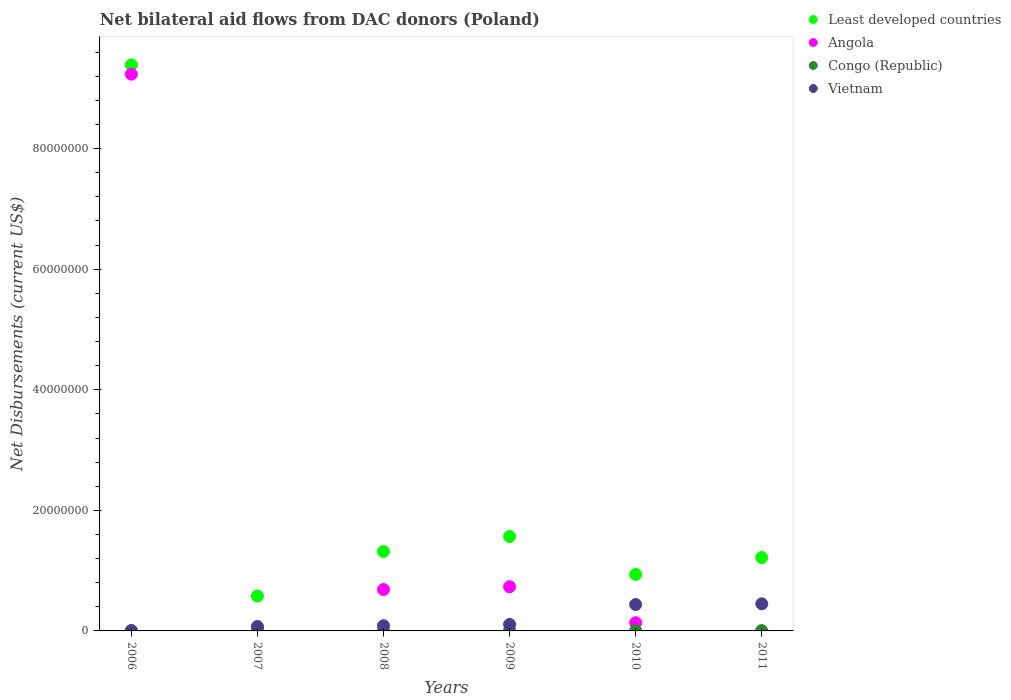What is the net bilateral aid flows in Vietnam in 2008?
Your response must be concise. 8.60e+05. Across all years, what is the maximum net bilateral aid flows in Least developed countries?
Your answer should be compact. 9.39e+07. Across all years, what is the minimum net bilateral aid flows in Vietnam?
Your answer should be very brief. 6.00e+04. In which year was the net bilateral aid flows in Least developed countries maximum?
Give a very brief answer. 2006. What is the total net bilateral aid flows in Vietnam in the graph?
Make the answer very short. 1.16e+07. What is the difference between the net bilateral aid flows in Congo (Republic) in 2007 and that in 2009?
Keep it short and to the point. 0. What is the difference between the net bilateral aid flows in Vietnam in 2009 and the net bilateral aid flows in Angola in 2008?
Make the answer very short. -5.79e+06. What is the average net bilateral aid flows in Least developed countries per year?
Make the answer very short. 2.50e+07. In the year 2011, what is the difference between the net bilateral aid flows in Congo (Republic) and net bilateral aid flows in Least developed countries?
Keep it short and to the point. -1.21e+07. What is the difference between the highest and the second highest net bilateral aid flows in Angola?
Offer a terse response. 8.50e+07. What is the difference between the highest and the lowest net bilateral aid flows in Angola?
Keep it short and to the point. 9.24e+07. Is the sum of the net bilateral aid flows in Congo (Republic) in 2007 and 2008 greater than the maximum net bilateral aid flows in Vietnam across all years?
Offer a terse response. No. Is it the case that in every year, the sum of the net bilateral aid flows in Vietnam and net bilateral aid flows in Least developed countries  is greater than the sum of net bilateral aid flows in Congo (Republic) and net bilateral aid flows in Angola?
Ensure brevity in your answer.  No. Is it the case that in every year, the sum of the net bilateral aid flows in Vietnam and net bilateral aid flows in Congo (Republic)  is greater than the net bilateral aid flows in Angola?
Offer a very short reply. No. Does the net bilateral aid flows in Vietnam monotonically increase over the years?
Offer a terse response. Yes. Is the net bilateral aid flows in Congo (Republic) strictly less than the net bilateral aid flows in Vietnam over the years?
Your answer should be very brief. Yes. Are the values on the major ticks of Y-axis written in scientific E-notation?
Your answer should be very brief. No. Does the graph contain any zero values?
Make the answer very short. Yes. How many legend labels are there?
Provide a succinct answer. 4. How are the legend labels stacked?
Your answer should be compact. Vertical. What is the title of the graph?
Make the answer very short. Net bilateral aid flows from DAC donors (Poland). What is the label or title of the Y-axis?
Keep it short and to the point. Net Disbursements (current US$). What is the Net Disbursements (current US$) of Least developed countries in 2006?
Provide a short and direct response. 9.39e+07. What is the Net Disbursements (current US$) in Angola in 2006?
Your answer should be very brief. 9.24e+07. What is the Net Disbursements (current US$) in Congo (Republic) in 2006?
Ensure brevity in your answer.  2.00e+04. What is the Net Disbursements (current US$) of Vietnam in 2006?
Keep it short and to the point. 6.00e+04. What is the Net Disbursements (current US$) of Least developed countries in 2007?
Keep it short and to the point. 5.79e+06. What is the Net Disbursements (current US$) of Vietnam in 2007?
Provide a succinct answer. 7.40e+05. What is the Net Disbursements (current US$) of Least developed countries in 2008?
Your answer should be compact. 1.32e+07. What is the Net Disbursements (current US$) in Angola in 2008?
Provide a succinct answer. 6.87e+06. What is the Net Disbursements (current US$) of Vietnam in 2008?
Your answer should be compact. 8.60e+05. What is the Net Disbursements (current US$) of Least developed countries in 2009?
Ensure brevity in your answer.  1.57e+07. What is the Net Disbursements (current US$) in Angola in 2009?
Make the answer very short. 7.33e+06. What is the Net Disbursements (current US$) in Vietnam in 2009?
Your answer should be compact. 1.08e+06. What is the Net Disbursements (current US$) of Least developed countries in 2010?
Your response must be concise. 9.37e+06. What is the Net Disbursements (current US$) of Angola in 2010?
Your answer should be very brief. 1.37e+06. What is the Net Disbursements (current US$) of Congo (Republic) in 2010?
Give a very brief answer. 4.00e+04. What is the Net Disbursements (current US$) in Vietnam in 2010?
Provide a succinct answer. 4.38e+06. What is the Net Disbursements (current US$) in Least developed countries in 2011?
Keep it short and to the point. 1.22e+07. What is the Net Disbursements (current US$) of Angola in 2011?
Your response must be concise. 0. What is the Net Disbursements (current US$) in Vietnam in 2011?
Provide a short and direct response. 4.50e+06. Across all years, what is the maximum Net Disbursements (current US$) in Least developed countries?
Make the answer very short. 9.39e+07. Across all years, what is the maximum Net Disbursements (current US$) in Angola?
Your response must be concise. 9.24e+07. Across all years, what is the maximum Net Disbursements (current US$) in Congo (Republic)?
Offer a terse response. 1.10e+05. Across all years, what is the maximum Net Disbursements (current US$) in Vietnam?
Keep it short and to the point. 4.50e+06. Across all years, what is the minimum Net Disbursements (current US$) of Least developed countries?
Provide a succinct answer. 5.79e+06. Across all years, what is the minimum Net Disbursements (current US$) in Vietnam?
Your answer should be compact. 6.00e+04. What is the total Net Disbursements (current US$) in Least developed countries in the graph?
Your answer should be very brief. 1.50e+08. What is the total Net Disbursements (current US$) of Angola in the graph?
Your answer should be very brief. 1.08e+08. What is the total Net Disbursements (current US$) of Congo (Republic) in the graph?
Make the answer very short. 3.80e+05. What is the total Net Disbursements (current US$) of Vietnam in the graph?
Offer a very short reply. 1.16e+07. What is the difference between the Net Disbursements (current US$) in Least developed countries in 2006 and that in 2007?
Your response must be concise. 8.81e+07. What is the difference between the Net Disbursements (current US$) in Angola in 2006 and that in 2007?
Your response must be concise. 9.19e+07. What is the difference between the Net Disbursements (current US$) of Congo (Republic) in 2006 and that in 2007?
Provide a short and direct response. -9.00e+04. What is the difference between the Net Disbursements (current US$) of Vietnam in 2006 and that in 2007?
Offer a terse response. -6.80e+05. What is the difference between the Net Disbursements (current US$) in Least developed countries in 2006 and that in 2008?
Keep it short and to the point. 8.07e+07. What is the difference between the Net Disbursements (current US$) of Angola in 2006 and that in 2008?
Provide a succinct answer. 8.55e+07. What is the difference between the Net Disbursements (current US$) of Congo (Republic) in 2006 and that in 2008?
Offer a terse response. -3.00e+04. What is the difference between the Net Disbursements (current US$) of Vietnam in 2006 and that in 2008?
Provide a succinct answer. -8.00e+05. What is the difference between the Net Disbursements (current US$) in Least developed countries in 2006 and that in 2009?
Make the answer very short. 7.82e+07. What is the difference between the Net Disbursements (current US$) of Angola in 2006 and that in 2009?
Provide a succinct answer. 8.50e+07. What is the difference between the Net Disbursements (current US$) in Vietnam in 2006 and that in 2009?
Keep it short and to the point. -1.02e+06. What is the difference between the Net Disbursements (current US$) of Least developed countries in 2006 and that in 2010?
Offer a terse response. 8.45e+07. What is the difference between the Net Disbursements (current US$) of Angola in 2006 and that in 2010?
Your response must be concise. 9.10e+07. What is the difference between the Net Disbursements (current US$) in Congo (Republic) in 2006 and that in 2010?
Offer a very short reply. -2.00e+04. What is the difference between the Net Disbursements (current US$) of Vietnam in 2006 and that in 2010?
Ensure brevity in your answer.  -4.32e+06. What is the difference between the Net Disbursements (current US$) in Least developed countries in 2006 and that in 2011?
Provide a short and direct response. 8.17e+07. What is the difference between the Net Disbursements (current US$) in Congo (Republic) in 2006 and that in 2011?
Give a very brief answer. -3.00e+04. What is the difference between the Net Disbursements (current US$) of Vietnam in 2006 and that in 2011?
Offer a very short reply. -4.44e+06. What is the difference between the Net Disbursements (current US$) of Least developed countries in 2007 and that in 2008?
Your answer should be very brief. -7.38e+06. What is the difference between the Net Disbursements (current US$) in Angola in 2007 and that in 2008?
Your answer should be compact. -6.38e+06. What is the difference between the Net Disbursements (current US$) of Vietnam in 2007 and that in 2008?
Offer a very short reply. -1.20e+05. What is the difference between the Net Disbursements (current US$) of Least developed countries in 2007 and that in 2009?
Make the answer very short. -9.87e+06. What is the difference between the Net Disbursements (current US$) of Angola in 2007 and that in 2009?
Your response must be concise. -6.84e+06. What is the difference between the Net Disbursements (current US$) in Congo (Republic) in 2007 and that in 2009?
Your answer should be compact. 0. What is the difference between the Net Disbursements (current US$) in Vietnam in 2007 and that in 2009?
Offer a very short reply. -3.40e+05. What is the difference between the Net Disbursements (current US$) in Least developed countries in 2007 and that in 2010?
Offer a terse response. -3.58e+06. What is the difference between the Net Disbursements (current US$) in Angola in 2007 and that in 2010?
Provide a succinct answer. -8.80e+05. What is the difference between the Net Disbursements (current US$) in Vietnam in 2007 and that in 2010?
Provide a succinct answer. -3.64e+06. What is the difference between the Net Disbursements (current US$) in Least developed countries in 2007 and that in 2011?
Offer a terse response. -6.38e+06. What is the difference between the Net Disbursements (current US$) of Congo (Republic) in 2007 and that in 2011?
Keep it short and to the point. 6.00e+04. What is the difference between the Net Disbursements (current US$) in Vietnam in 2007 and that in 2011?
Ensure brevity in your answer.  -3.76e+06. What is the difference between the Net Disbursements (current US$) in Least developed countries in 2008 and that in 2009?
Provide a short and direct response. -2.49e+06. What is the difference between the Net Disbursements (current US$) of Angola in 2008 and that in 2009?
Provide a short and direct response. -4.60e+05. What is the difference between the Net Disbursements (current US$) in Congo (Republic) in 2008 and that in 2009?
Offer a terse response. -6.00e+04. What is the difference between the Net Disbursements (current US$) in Vietnam in 2008 and that in 2009?
Offer a very short reply. -2.20e+05. What is the difference between the Net Disbursements (current US$) of Least developed countries in 2008 and that in 2010?
Give a very brief answer. 3.80e+06. What is the difference between the Net Disbursements (current US$) of Angola in 2008 and that in 2010?
Offer a very short reply. 5.50e+06. What is the difference between the Net Disbursements (current US$) in Congo (Republic) in 2008 and that in 2010?
Provide a succinct answer. 10000. What is the difference between the Net Disbursements (current US$) in Vietnam in 2008 and that in 2010?
Offer a very short reply. -3.52e+06. What is the difference between the Net Disbursements (current US$) of Vietnam in 2008 and that in 2011?
Your answer should be very brief. -3.64e+06. What is the difference between the Net Disbursements (current US$) in Least developed countries in 2009 and that in 2010?
Keep it short and to the point. 6.29e+06. What is the difference between the Net Disbursements (current US$) in Angola in 2009 and that in 2010?
Give a very brief answer. 5.96e+06. What is the difference between the Net Disbursements (current US$) in Vietnam in 2009 and that in 2010?
Provide a short and direct response. -3.30e+06. What is the difference between the Net Disbursements (current US$) of Least developed countries in 2009 and that in 2011?
Give a very brief answer. 3.49e+06. What is the difference between the Net Disbursements (current US$) in Congo (Republic) in 2009 and that in 2011?
Provide a short and direct response. 6.00e+04. What is the difference between the Net Disbursements (current US$) of Vietnam in 2009 and that in 2011?
Ensure brevity in your answer.  -3.42e+06. What is the difference between the Net Disbursements (current US$) in Least developed countries in 2010 and that in 2011?
Make the answer very short. -2.80e+06. What is the difference between the Net Disbursements (current US$) in Congo (Republic) in 2010 and that in 2011?
Ensure brevity in your answer.  -10000. What is the difference between the Net Disbursements (current US$) in Least developed countries in 2006 and the Net Disbursements (current US$) in Angola in 2007?
Your answer should be compact. 9.34e+07. What is the difference between the Net Disbursements (current US$) of Least developed countries in 2006 and the Net Disbursements (current US$) of Congo (Republic) in 2007?
Give a very brief answer. 9.38e+07. What is the difference between the Net Disbursements (current US$) of Least developed countries in 2006 and the Net Disbursements (current US$) of Vietnam in 2007?
Your answer should be very brief. 9.32e+07. What is the difference between the Net Disbursements (current US$) of Angola in 2006 and the Net Disbursements (current US$) of Congo (Republic) in 2007?
Make the answer very short. 9.22e+07. What is the difference between the Net Disbursements (current US$) of Angola in 2006 and the Net Disbursements (current US$) of Vietnam in 2007?
Offer a terse response. 9.16e+07. What is the difference between the Net Disbursements (current US$) in Congo (Republic) in 2006 and the Net Disbursements (current US$) in Vietnam in 2007?
Ensure brevity in your answer.  -7.20e+05. What is the difference between the Net Disbursements (current US$) in Least developed countries in 2006 and the Net Disbursements (current US$) in Angola in 2008?
Your response must be concise. 8.70e+07. What is the difference between the Net Disbursements (current US$) in Least developed countries in 2006 and the Net Disbursements (current US$) in Congo (Republic) in 2008?
Your answer should be very brief. 9.38e+07. What is the difference between the Net Disbursements (current US$) in Least developed countries in 2006 and the Net Disbursements (current US$) in Vietnam in 2008?
Keep it short and to the point. 9.30e+07. What is the difference between the Net Disbursements (current US$) in Angola in 2006 and the Net Disbursements (current US$) in Congo (Republic) in 2008?
Provide a succinct answer. 9.23e+07. What is the difference between the Net Disbursements (current US$) of Angola in 2006 and the Net Disbursements (current US$) of Vietnam in 2008?
Provide a succinct answer. 9.15e+07. What is the difference between the Net Disbursements (current US$) of Congo (Republic) in 2006 and the Net Disbursements (current US$) of Vietnam in 2008?
Provide a short and direct response. -8.40e+05. What is the difference between the Net Disbursements (current US$) in Least developed countries in 2006 and the Net Disbursements (current US$) in Angola in 2009?
Keep it short and to the point. 8.66e+07. What is the difference between the Net Disbursements (current US$) in Least developed countries in 2006 and the Net Disbursements (current US$) in Congo (Republic) in 2009?
Your answer should be compact. 9.38e+07. What is the difference between the Net Disbursements (current US$) of Least developed countries in 2006 and the Net Disbursements (current US$) of Vietnam in 2009?
Your response must be concise. 9.28e+07. What is the difference between the Net Disbursements (current US$) of Angola in 2006 and the Net Disbursements (current US$) of Congo (Republic) in 2009?
Offer a terse response. 9.22e+07. What is the difference between the Net Disbursements (current US$) of Angola in 2006 and the Net Disbursements (current US$) of Vietnam in 2009?
Your response must be concise. 9.13e+07. What is the difference between the Net Disbursements (current US$) in Congo (Republic) in 2006 and the Net Disbursements (current US$) in Vietnam in 2009?
Your answer should be very brief. -1.06e+06. What is the difference between the Net Disbursements (current US$) in Least developed countries in 2006 and the Net Disbursements (current US$) in Angola in 2010?
Your answer should be compact. 9.25e+07. What is the difference between the Net Disbursements (current US$) of Least developed countries in 2006 and the Net Disbursements (current US$) of Congo (Republic) in 2010?
Your answer should be compact. 9.38e+07. What is the difference between the Net Disbursements (current US$) in Least developed countries in 2006 and the Net Disbursements (current US$) in Vietnam in 2010?
Your answer should be very brief. 8.95e+07. What is the difference between the Net Disbursements (current US$) of Angola in 2006 and the Net Disbursements (current US$) of Congo (Republic) in 2010?
Keep it short and to the point. 9.23e+07. What is the difference between the Net Disbursements (current US$) in Angola in 2006 and the Net Disbursements (current US$) in Vietnam in 2010?
Offer a terse response. 8.80e+07. What is the difference between the Net Disbursements (current US$) of Congo (Republic) in 2006 and the Net Disbursements (current US$) of Vietnam in 2010?
Offer a very short reply. -4.36e+06. What is the difference between the Net Disbursements (current US$) in Least developed countries in 2006 and the Net Disbursements (current US$) in Congo (Republic) in 2011?
Your answer should be very brief. 9.38e+07. What is the difference between the Net Disbursements (current US$) in Least developed countries in 2006 and the Net Disbursements (current US$) in Vietnam in 2011?
Make the answer very short. 8.94e+07. What is the difference between the Net Disbursements (current US$) in Angola in 2006 and the Net Disbursements (current US$) in Congo (Republic) in 2011?
Your answer should be compact. 9.23e+07. What is the difference between the Net Disbursements (current US$) in Angola in 2006 and the Net Disbursements (current US$) in Vietnam in 2011?
Your response must be concise. 8.78e+07. What is the difference between the Net Disbursements (current US$) in Congo (Republic) in 2006 and the Net Disbursements (current US$) in Vietnam in 2011?
Offer a terse response. -4.48e+06. What is the difference between the Net Disbursements (current US$) in Least developed countries in 2007 and the Net Disbursements (current US$) in Angola in 2008?
Provide a succinct answer. -1.08e+06. What is the difference between the Net Disbursements (current US$) in Least developed countries in 2007 and the Net Disbursements (current US$) in Congo (Republic) in 2008?
Your answer should be very brief. 5.74e+06. What is the difference between the Net Disbursements (current US$) of Least developed countries in 2007 and the Net Disbursements (current US$) of Vietnam in 2008?
Your response must be concise. 4.93e+06. What is the difference between the Net Disbursements (current US$) of Angola in 2007 and the Net Disbursements (current US$) of Congo (Republic) in 2008?
Offer a terse response. 4.40e+05. What is the difference between the Net Disbursements (current US$) in Angola in 2007 and the Net Disbursements (current US$) in Vietnam in 2008?
Make the answer very short. -3.70e+05. What is the difference between the Net Disbursements (current US$) of Congo (Republic) in 2007 and the Net Disbursements (current US$) of Vietnam in 2008?
Provide a short and direct response. -7.50e+05. What is the difference between the Net Disbursements (current US$) of Least developed countries in 2007 and the Net Disbursements (current US$) of Angola in 2009?
Offer a very short reply. -1.54e+06. What is the difference between the Net Disbursements (current US$) in Least developed countries in 2007 and the Net Disbursements (current US$) in Congo (Republic) in 2009?
Ensure brevity in your answer.  5.68e+06. What is the difference between the Net Disbursements (current US$) in Least developed countries in 2007 and the Net Disbursements (current US$) in Vietnam in 2009?
Your response must be concise. 4.71e+06. What is the difference between the Net Disbursements (current US$) in Angola in 2007 and the Net Disbursements (current US$) in Congo (Republic) in 2009?
Your answer should be very brief. 3.80e+05. What is the difference between the Net Disbursements (current US$) of Angola in 2007 and the Net Disbursements (current US$) of Vietnam in 2009?
Make the answer very short. -5.90e+05. What is the difference between the Net Disbursements (current US$) of Congo (Republic) in 2007 and the Net Disbursements (current US$) of Vietnam in 2009?
Give a very brief answer. -9.70e+05. What is the difference between the Net Disbursements (current US$) of Least developed countries in 2007 and the Net Disbursements (current US$) of Angola in 2010?
Offer a very short reply. 4.42e+06. What is the difference between the Net Disbursements (current US$) of Least developed countries in 2007 and the Net Disbursements (current US$) of Congo (Republic) in 2010?
Offer a terse response. 5.75e+06. What is the difference between the Net Disbursements (current US$) of Least developed countries in 2007 and the Net Disbursements (current US$) of Vietnam in 2010?
Offer a very short reply. 1.41e+06. What is the difference between the Net Disbursements (current US$) of Angola in 2007 and the Net Disbursements (current US$) of Congo (Republic) in 2010?
Offer a terse response. 4.50e+05. What is the difference between the Net Disbursements (current US$) in Angola in 2007 and the Net Disbursements (current US$) in Vietnam in 2010?
Ensure brevity in your answer.  -3.89e+06. What is the difference between the Net Disbursements (current US$) of Congo (Republic) in 2007 and the Net Disbursements (current US$) of Vietnam in 2010?
Make the answer very short. -4.27e+06. What is the difference between the Net Disbursements (current US$) of Least developed countries in 2007 and the Net Disbursements (current US$) of Congo (Republic) in 2011?
Keep it short and to the point. 5.74e+06. What is the difference between the Net Disbursements (current US$) of Least developed countries in 2007 and the Net Disbursements (current US$) of Vietnam in 2011?
Give a very brief answer. 1.29e+06. What is the difference between the Net Disbursements (current US$) in Angola in 2007 and the Net Disbursements (current US$) in Vietnam in 2011?
Give a very brief answer. -4.01e+06. What is the difference between the Net Disbursements (current US$) of Congo (Republic) in 2007 and the Net Disbursements (current US$) of Vietnam in 2011?
Your answer should be very brief. -4.39e+06. What is the difference between the Net Disbursements (current US$) of Least developed countries in 2008 and the Net Disbursements (current US$) of Angola in 2009?
Keep it short and to the point. 5.84e+06. What is the difference between the Net Disbursements (current US$) of Least developed countries in 2008 and the Net Disbursements (current US$) of Congo (Republic) in 2009?
Your response must be concise. 1.31e+07. What is the difference between the Net Disbursements (current US$) in Least developed countries in 2008 and the Net Disbursements (current US$) in Vietnam in 2009?
Your response must be concise. 1.21e+07. What is the difference between the Net Disbursements (current US$) of Angola in 2008 and the Net Disbursements (current US$) of Congo (Republic) in 2009?
Offer a very short reply. 6.76e+06. What is the difference between the Net Disbursements (current US$) in Angola in 2008 and the Net Disbursements (current US$) in Vietnam in 2009?
Offer a very short reply. 5.79e+06. What is the difference between the Net Disbursements (current US$) of Congo (Republic) in 2008 and the Net Disbursements (current US$) of Vietnam in 2009?
Make the answer very short. -1.03e+06. What is the difference between the Net Disbursements (current US$) in Least developed countries in 2008 and the Net Disbursements (current US$) in Angola in 2010?
Your answer should be very brief. 1.18e+07. What is the difference between the Net Disbursements (current US$) in Least developed countries in 2008 and the Net Disbursements (current US$) in Congo (Republic) in 2010?
Your response must be concise. 1.31e+07. What is the difference between the Net Disbursements (current US$) of Least developed countries in 2008 and the Net Disbursements (current US$) of Vietnam in 2010?
Keep it short and to the point. 8.79e+06. What is the difference between the Net Disbursements (current US$) of Angola in 2008 and the Net Disbursements (current US$) of Congo (Republic) in 2010?
Give a very brief answer. 6.83e+06. What is the difference between the Net Disbursements (current US$) of Angola in 2008 and the Net Disbursements (current US$) of Vietnam in 2010?
Your answer should be compact. 2.49e+06. What is the difference between the Net Disbursements (current US$) in Congo (Republic) in 2008 and the Net Disbursements (current US$) in Vietnam in 2010?
Your answer should be very brief. -4.33e+06. What is the difference between the Net Disbursements (current US$) of Least developed countries in 2008 and the Net Disbursements (current US$) of Congo (Republic) in 2011?
Your answer should be very brief. 1.31e+07. What is the difference between the Net Disbursements (current US$) of Least developed countries in 2008 and the Net Disbursements (current US$) of Vietnam in 2011?
Your answer should be very brief. 8.67e+06. What is the difference between the Net Disbursements (current US$) of Angola in 2008 and the Net Disbursements (current US$) of Congo (Republic) in 2011?
Provide a short and direct response. 6.82e+06. What is the difference between the Net Disbursements (current US$) of Angola in 2008 and the Net Disbursements (current US$) of Vietnam in 2011?
Keep it short and to the point. 2.37e+06. What is the difference between the Net Disbursements (current US$) of Congo (Republic) in 2008 and the Net Disbursements (current US$) of Vietnam in 2011?
Your answer should be very brief. -4.45e+06. What is the difference between the Net Disbursements (current US$) in Least developed countries in 2009 and the Net Disbursements (current US$) in Angola in 2010?
Keep it short and to the point. 1.43e+07. What is the difference between the Net Disbursements (current US$) of Least developed countries in 2009 and the Net Disbursements (current US$) of Congo (Republic) in 2010?
Your answer should be compact. 1.56e+07. What is the difference between the Net Disbursements (current US$) of Least developed countries in 2009 and the Net Disbursements (current US$) of Vietnam in 2010?
Your answer should be very brief. 1.13e+07. What is the difference between the Net Disbursements (current US$) of Angola in 2009 and the Net Disbursements (current US$) of Congo (Republic) in 2010?
Offer a terse response. 7.29e+06. What is the difference between the Net Disbursements (current US$) of Angola in 2009 and the Net Disbursements (current US$) of Vietnam in 2010?
Give a very brief answer. 2.95e+06. What is the difference between the Net Disbursements (current US$) in Congo (Republic) in 2009 and the Net Disbursements (current US$) in Vietnam in 2010?
Keep it short and to the point. -4.27e+06. What is the difference between the Net Disbursements (current US$) of Least developed countries in 2009 and the Net Disbursements (current US$) of Congo (Republic) in 2011?
Offer a very short reply. 1.56e+07. What is the difference between the Net Disbursements (current US$) in Least developed countries in 2009 and the Net Disbursements (current US$) in Vietnam in 2011?
Offer a terse response. 1.12e+07. What is the difference between the Net Disbursements (current US$) in Angola in 2009 and the Net Disbursements (current US$) in Congo (Republic) in 2011?
Provide a succinct answer. 7.28e+06. What is the difference between the Net Disbursements (current US$) of Angola in 2009 and the Net Disbursements (current US$) of Vietnam in 2011?
Provide a succinct answer. 2.83e+06. What is the difference between the Net Disbursements (current US$) in Congo (Republic) in 2009 and the Net Disbursements (current US$) in Vietnam in 2011?
Your answer should be compact. -4.39e+06. What is the difference between the Net Disbursements (current US$) in Least developed countries in 2010 and the Net Disbursements (current US$) in Congo (Republic) in 2011?
Provide a succinct answer. 9.32e+06. What is the difference between the Net Disbursements (current US$) of Least developed countries in 2010 and the Net Disbursements (current US$) of Vietnam in 2011?
Offer a very short reply. 4.87e+06. What is the difference between the Net Disbursements (current US$) in Angola in 2010 and the Net Disbursements (current US$) in Congo (Republic) in 2011?
Ensure brevity in your answer.  1.32e+06. What is the difference between the Net Disbursements (current US$) of Angola in 2010 and the Net Disbursements (current US$) of Vietnam in 2011?
Ensure brevity in your answer.  -3.13e+06. What is the difference between the Net Disbursements (current US$) of Congo (Republic) in 2010 and the Net Disbursements (current US$) of Vietnam in 2011?
Offer a terse response. -4.46e+06. What is the average Net Disbursements (current US$) of Least developed countries per year?
Make the answer very short. 2.50e+07. What is the average Net Disbursements (current US$) of Angola per year?
Your answer should be very brief. 1.81e+07. What is the average Net Disbursements (current US$) in Congo (Republic) per year?
Make the answer very short. 6.33e+04. What is the average Net Disbursements (current US$) of Vietnam per year?
Ensure brevity in your answer.  1.94e+06. In the year 2006, what is the difference between the Net Disbursements (current US$) in Least developed countries and Net Disbursements (current US$) in Angola?
Ensure brevity in your answer.  1.54e+06. In the year 2006, what is the difference between the Net Disbursements (current US$) in Least developed countries and Net Disbursements (current US$) in Congo (Republic)?
Your response must be concise. 9.39e+07. In the year 2006, what is the difference between the Net Disbursements (current US$) in Least developed countries and Net Disbursements (current US$) in Vietnam?
Your answer should be very brief. 9.38e+07. In the year 2006, what is the difference between the Net Disbursements (current US$) in Angola and Net Disbursements (current US$) in Congo (Republic)?
Give a very brief answer. 9.23e+07. In the year 2006, what is the difference between the Net Disbursements (current US$) of Angola and Net Disbursements (current US$) of Vietnam?
Provide a short and direct response. 9.23e+07. In the year 2006, what is the difference between the Net Disbursements (current US$) of Congo (Republic) and Net Disbursements (current US$) of Vietnam?
Provide a short and direct response. -4.00e+04. In the year 2007, what is the difference between the Net Disbursements (current US$) of Least developed countries and Net Disbursements (current US$) of Angola?
Ensure brevity in your answer.  5.30e+06. In the year 2007, what is the difference between the Net Disbursements (current US$) in Least developed countries and Net Disbursements (current US$) in Congo (Republic)?
Keep it short and to the point. 5.68e+06. In the year 2007, what is the difference between the Net Disbursements (current US$) in Least developed countries and Net Disbursements (current US$) in Vietnam?
Provide a succinct answer. 5.05e+06. In the year 2007, what is the difference between the Net Disbursements (current US$) of Congo (Republic) and Net Disbursements (current US$) of Vietnam?
Your answer should be compact. -6.30e+05. In the year 2008, what is the difference between the Net Disbursements (current US$) in Least developed countries and Net Disbursements (current US$) in Angola?
Keep it short and to the point. 6.30e+06. In the year 2008, what is the difference between the Net Disbursements (current US$) of Least developed countries and Net Disbursements (current US$) of Congo (Republic)?
Keep it short and to the point. 1.31e+07. In the year 2008, what is the difference between the Net Disbursements (current US$) of Least developed countries and Net Disbursements (current US$) of Vietnam?
Ensure brevity in your answer.  1.23e+07. In the year 2008, what is the difference between the Net Disbursements (current US$) in Angola and Net Disbursements (current US$) in Congo (Republic)?
Your answer should be very brief. 6.82e+06. In the year 2008, what is the difference between the Net Disbursements (current US$) of Angola and Net Disbursements (current US$) of Vietnam?
Keep it short and to the point. 6.01e+06. In the year 2008, what is the difference between the Net Disbursements (current US$) of Congo (Republic) and Net Disbursements (current US$) of Vietnam?
Give a very brief answer. -8.10e+05. In the year 2009, what is the difference between the Net Disbursements (current US$) in Least developed countries and Net Disbursements (current US$) in Angola?
Make the answer very short. 8.33e+06. In the year 2009, what is the difference between the Net Disbursements (current US$) in Least developed countries and Net Disbursements (current US$) in Congo (Republic)?
Provide a short and direct response. 1.56e+07. In the year 2009, what is the difference between the Net Disbursements (current US$) in Least developed countries and Net Disbursements (current US$) in Vietnam?
Provide a short and direct response. 1.46e+07. In the year 2009, what is the difference between the Net Disbursements (current US$) of Angola and Net Disbursements (current US$) of Congo (Republic)?
Keep it short and to the point. 7.22e+06. In the year 2009, what is the difference between the Net Disbursements (current US$) of Angola and Net Disbursements (current US$) of Vietnam?
Provide a short and direct response. 6.25e+06. In the year 2009, what is the difference between the Net Disbursements (current US$) of Congo (Republic) and Net Disbursements (current US$) of Vietnam?
Your answer should be very brief. -9.70e+05. In the year 2010, what is the difference between the Net Disbursements (current US$) in Least developed countries and Net Disbursements (current US$) in Angola?
Provide a succinct answer. 8.00e+06. In the year 2010, what is the difference between the Net Disbursements (current US$) of Least developed countries and Net Disbursements (current US$) of Congo (Republic)?
Give a very brief answer. 9.33e+06. In the year 2010, what is the difference between the Net Disbursements (current US$) in Least developed countries and Net Disbursements (current US$) in Vietnam?
Your answer should be very brief. 4.99e+06. In the year 2010, what is the difference between the Net Disbursements (current US$) in Angola and Net Disbursements (current US$) in Congo (Republic)?
Your response must be concise. 1.33e+06. In the year 2010, what is the difference between the Net Disbursements (current US$) in Angola and Net Disbursements (current US$) in Vietnam?
Provide a short and direct response. -3.01e+06. In the year 2010, what is the difference between the Net Disbursements (current US$) of Congo (Republic) and Net Disbursements (current US$) of Vietnam?
Keep it short and to the point. -4.34e+06. In the year 2011, what is the difference between the Net Disbursements (current US$) in Least developed countries and Net Disbursements (current US$) in Congo (Republic)?
Keep it short and to the point. 1.21e+07. In the year 2011, what is the difference between the Net Disbursements (current US$) in Least developed countries and Net Disbursements (current US$) in Vietnam?
Offer a terse response. 7.67e+06. In the year 2011, what is the difference between the Net Disbursements (current US$) in Congo (Republic) and Net Disbursements (current US$) in Vietnam?
Provide a succinct answer. -4.45e+06. What is the ratio of the Net Disbursements (current US$) of Least developed countries in 2006 to that in 2007?
Provide a short and direct response. 16.22. What is the ratio of the Net Disbursements (current US$) of Angola in 2006 to that in 2007?
Make the answer very short. 188.47. What is the ratio of the Net Disbursements (current US$) of Congo (Republic) in 2006 to that in 2007?
Your answer should be very brief. 0.18. What is the ratio of the Net Disbursements (current US$) of Vietnam in 2006 to that in 2007?
Give a very brief answer. 0.08. What is the ratio of the Net Disbursements (current US$) in Least developed countries in 2006 to that in 2008?
Provide a short and direct response. 7.13. What is the ratio of the Net Disbursements (current US$) of Angola in 2006 to that in 2008?
Keep it short and to the point. 13.44. What is the ratio of the Net Disbursements (current US$) in Vietnam in 2006 to that in 2008?
Provide a short and direct response. 0.07. What is the ratio of the Net Disbursements (current US$) in Least developed countries in 2006 to that in 2009?
Give a very brief answer. 6. What is the ratio of the Net Disbursements (current US$) of Angola in 2006 to that in 2009?
Ensure brevity in your answer.  12.6. What is the ratio of the Net Disbursements (current US$) in Congo (Republic) in 2006 to that in 2009?
Provide a short and direct response. 0.18. What is the ratio of the Net Disbursements (current US$) of Vietnam in 2006 to that in 2009?
Provide a short and direct response. 0.06. What is the ratio of the Net Disbursements (current US$) of Least developed countries in 2006 to that in 2010?
Make the answer very short. 10.02. What is the ratio of the Net Disbursements (current US$) in Angola in 2006 to that in 2010?
Your response must be concise. 67.41. What is the ratio of the Net Disbursements (current US$) of Congo (Republic) in 2006 to that in 2010?
Offer a very short reply. 0.5. What is the ratio of the Net Disbursements (current US$) of Vietnam in 2006 to that in 2010?
Your response must be concise. 0.01. What is the ratio of the Net Disbursements (current US$) of Least developed countries in 2006 to that in 2011?
Your response must be concise. 7.71. What is the ratio of the Net Disbursements (current US$) in Vietnam in 2006 to that in 2011?
Your answer should be very brief. 0.01. What is the ratio of the Net Disbursements (current US$) in Least developed countries in 2007 to that in 2008?
Keep it short and to the point. 0.44. What is the ratio of the Net Disbursements (current US$) in Angola in 2007 to that in 2008?
Offer a very short reply. 0.07. What is the ratio of the Net Disbursements (current US$) in Vietnam in 2007 to that in 2008?
Your answer should be very brief. 0.86. What is the ratio of the Net Disbursements (current US$) of Least developed countries in 2007 to that in 2009?
Ensure brevity in your answer.  0.37. What is the ratio of the Net Disbursements (current US$) in Angola in 2007 to that in 2009?
Give a very brief answer. 0.07. What is the ratio of the Net Disbursements (current US$) in Vietnam in 2007 to that in 2009?
Make the answer very short. 0.69. What is the ratio of the Net Disbursements (current US$) of Least developed countries in 2007 to that in 2010?
Ensure brevity in your answer.  0.62. What is the ratio of the Net Disbursements (current US$) of Angola in 2007 to that in 2010?
Keep it short and to the point. 0.36. What is the ratio of the Net Disbursements (current US$) in Congo (Republic) in 2007 to that in 2010?
Your answer should be compact. 2.75. What is the ratio of the Net Disbursements (current US$) in Vietnam in 2007 to that in 2010?
Provide a succinct answer. 0.17. What is the ratio of the Net Disbursements (current US$) of Least developed countries in 2007 to that in 2011?
Give a very brief answer. 0.48. What is the ratio of the Net Disbursements (current US$) in Vietnam in 2007 to that in 2011?
Your response must be concise. 0.16. What is the ratio of the Net Disbursements (current US$) of Least developed countries in 2008 to that in 2009?
Your answer should be very brief. 0.84. What is the ratio of the Net Disbursements (current US$) in Angola in 2008 to that in 2009?
Your answer should be compact. 0.94. What is the ratio of the Net Disbursements (current US$) in Congo (Republic) in 2008 to that in 2009?
Offer a very short reply. 0.45. What is the ratio of the Net Disbursements (current US$) in Vietnam in 2008 to that in 2009?
Keep it short and to the point. 0.8. What is the ratio of the Net Disbursements (current US$) of Least developed countries in 2008 to that in 2010?
Give a very brief answer. 1.41. What is the ratio of the Net Disbursements (current US$) of Angola in 2008 to that in 2010?
Keep it short and to the point. 5.01. What is the ratio of the Net Disbursements (current US$) of Congo (Republic) in 2008 to that in 2010?
Keep it short and to the point. 1.25. What is the ratio of the Net Disbursements (current US$) in Vietnam in 2008 to that in 2010?
Ensure brevity in your answer.  0.2. What is the ratio of the Net Disbursements (current US$) of Least developed countries in 2008 to that in 2011?
Provide a short and direct response. 1.08. What is the ratio of the Net Disbursements (current US$) of Congo (Republic) in 2008 to that in 2011?
Offer a terse response. 1. What is the ratio of the Net Disbursements (current US$) in Vietnam in 2008 to that in 2011?
Offer a very short reply. 0.19. What is the ratio of the Net Disbursements (current US$) of Least developed countries in 2009 to that in 2010?
Provide a short and direct response. 1.67. What is the ratio of the Net Disbursements (current US$) in Angola in 2009 to that in 2010?
Ensure brevity in your answer.  5.35. What is the ratio of the Net Disbursements (current US$) in Congo (Republic) in 2009 to that in 2010?
Your answer should be compact. 2.75. What is the ratio of the Net Disbursements (current US$) in Vietnam in 2009 to that in 2010?
Your answer should be compact. 0.25. What is the ratio of the Net Disbursements (current US$) in Least developed countries in 2009 to that in 2011?
Your answer should be very brief. 1.29. What is the ratio of the Net Disbursements (current US$) of Congo (Republic) in 2009 to that in 2011?
Your answer should be very brief. 2.2. What is the ratio of the Net Disbursements (current US$) of Vietnam in 2009 to that in 2011?
Ensure brevity in your answer.  0.24. What is the ratio of the Net Disbursements (current US$) of Least developed countries in 2010 to that in 2011?
Provide a succinct answer. 0.77. What is the ratio of the Net Disbursements (current US$) of Congo (Republic) in 2010 to that in 2011?
Your answer should be very brief. 0.8. What is the ratio of the Net Disbursements (current US$) in Vietnam in 2010 to that in 2011?
Provide a short and direct response. 0.97. What is the difference between the highest and the second highest Net Disbursements (current US$) of Least developed countries?
Offer a terse response. 7.82e+07. What is the difference between the highest and the second highest Net Disbursements (current US$) in Angola?
Give a very brief answer. 8.50e+07. What is the difference between the highest and the lowest Net Disbursements (current US$) in Least developed countries?
Your response must be concise. 8.81e+07. What is the difference between the highest and the lowest Net Disbursements (current US$) in Angola?
Provide a short and direct response. 9.24e+07. What is the difference between the highest and the lowest Net Disbursements (current US$) in Congo (Republic)?
Provide a short and direct response. 9.00e+04. What is the difference between the highest and the lowest Net Disbursements (current US$) of Vietnam?
Keep it short and to the point. 4.44e+06. 